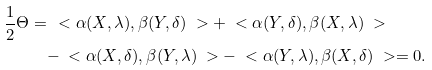<formula> <loc_0><loc_0><loc_500><loc_500>\frac { 1 } { 2 } \Theta = & \, \ < \alpha ( X , \lambda ) , \beta ( Y , \delta ) \ > + \ < \alpha ( Y , \delta ) , \beta ( X , \lambda ) \ > \\ & - \ < \alpha ( X , \delta ) , \beta ( Y , \lambda ) \ > - \ < \alpha ( Y , \lambda ) , \beta ( X , \delta ) \ > = 0 .</formula> 